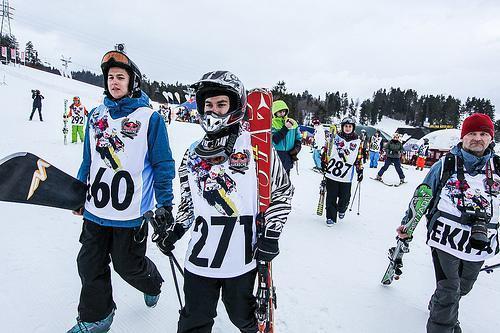How many people have on a red hat?
Give a very brief answer. 1. 